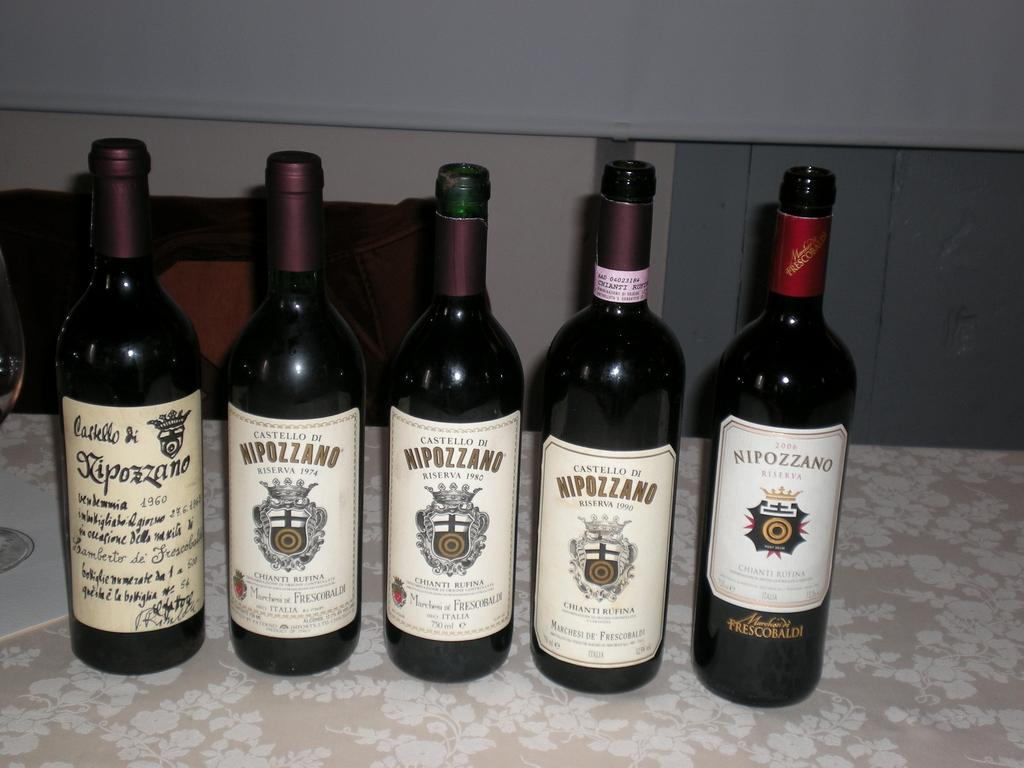<image>
Create a compact narrative representing the image presented. some bottles with one that says Nipozzano on it 